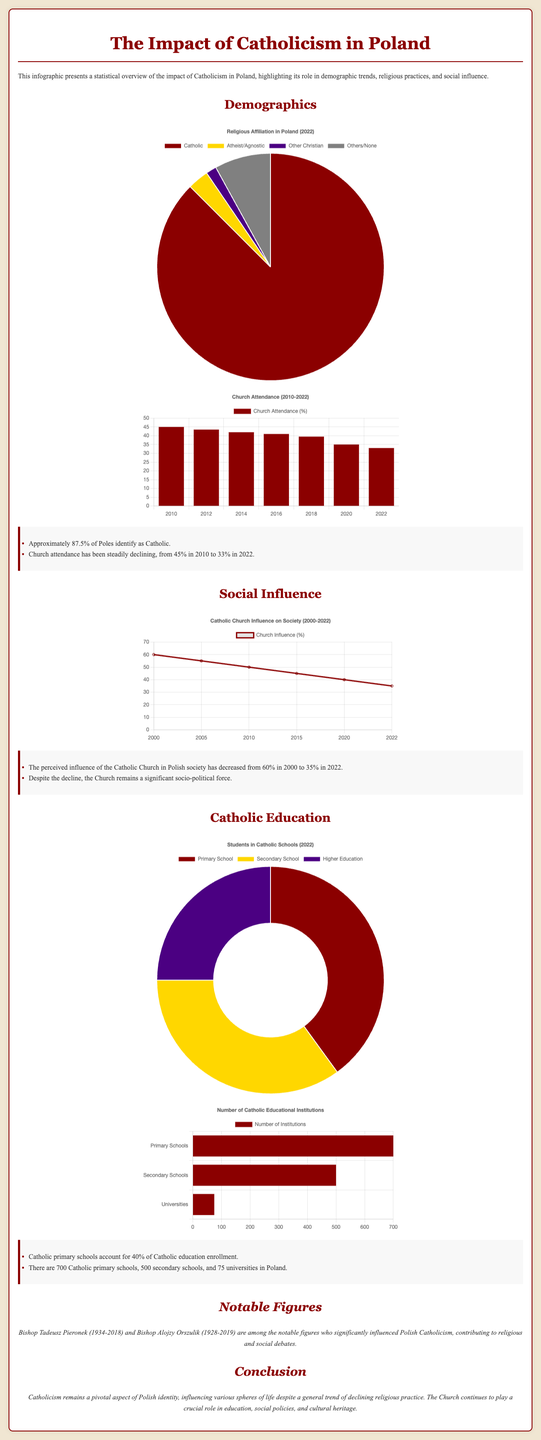what percentage of Poles identify as Catholic? The document states that approximately 87.5% of Poles identify as Catholic.
Answer: 87.5% what was the church attendance percentage in 2010? According to the document, church attendance in 2010 was 45%.
Answer: 45% how many Catholic primary schools are in Poland? The key findings mention there are 700 Catholic primary schools in Poland.
Answer: 700 what is the lowest church attendance percentage reported in the document? The document indicates that the lowest church attendance was 33% in 2022.
Answer: 33% what was the perceived influence of the Catholic Church in 2000? The document notes that the perceived influence of the Church was 60% in 2000.
Answer: 60% how many universities are there in Poland according to the document? The document indicates there are 75 Catholic universities in Poland.
Answer: 75 in what year did the perceived influence of the Catholic Church drop to 35%? The document states that the perceived influence dropped to 35% in 2022.
Answer: 2022 what type of chart shows religious affiliation in Poland? The infographic uses a pie chart to display the religious affiliation in Poland.
Answer: Pie chart which notable figure significantly influenced Polish Catholicism? The document mentions Bishop Tadeusz Pieronek as a notable figure.
Answer: Bishop Tadeusz Pieronek 